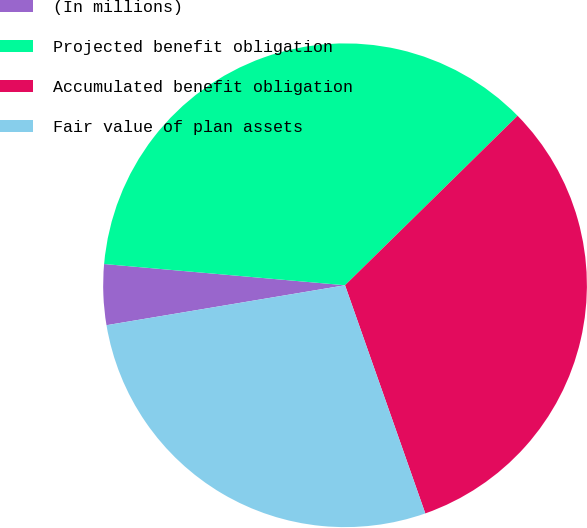<chart> <loc_0><loc_0><loc_500><loc_500><pie_chart><fcel>(In millions)<fcel>Projected benefit obligation<fcel>Accumulated benefit obligation<fcel>Fair value of plan assets<nl><fcel>4.04%<fcel>36.24%<fcel>31.97%<fcel>27.74%<nl></chart> 